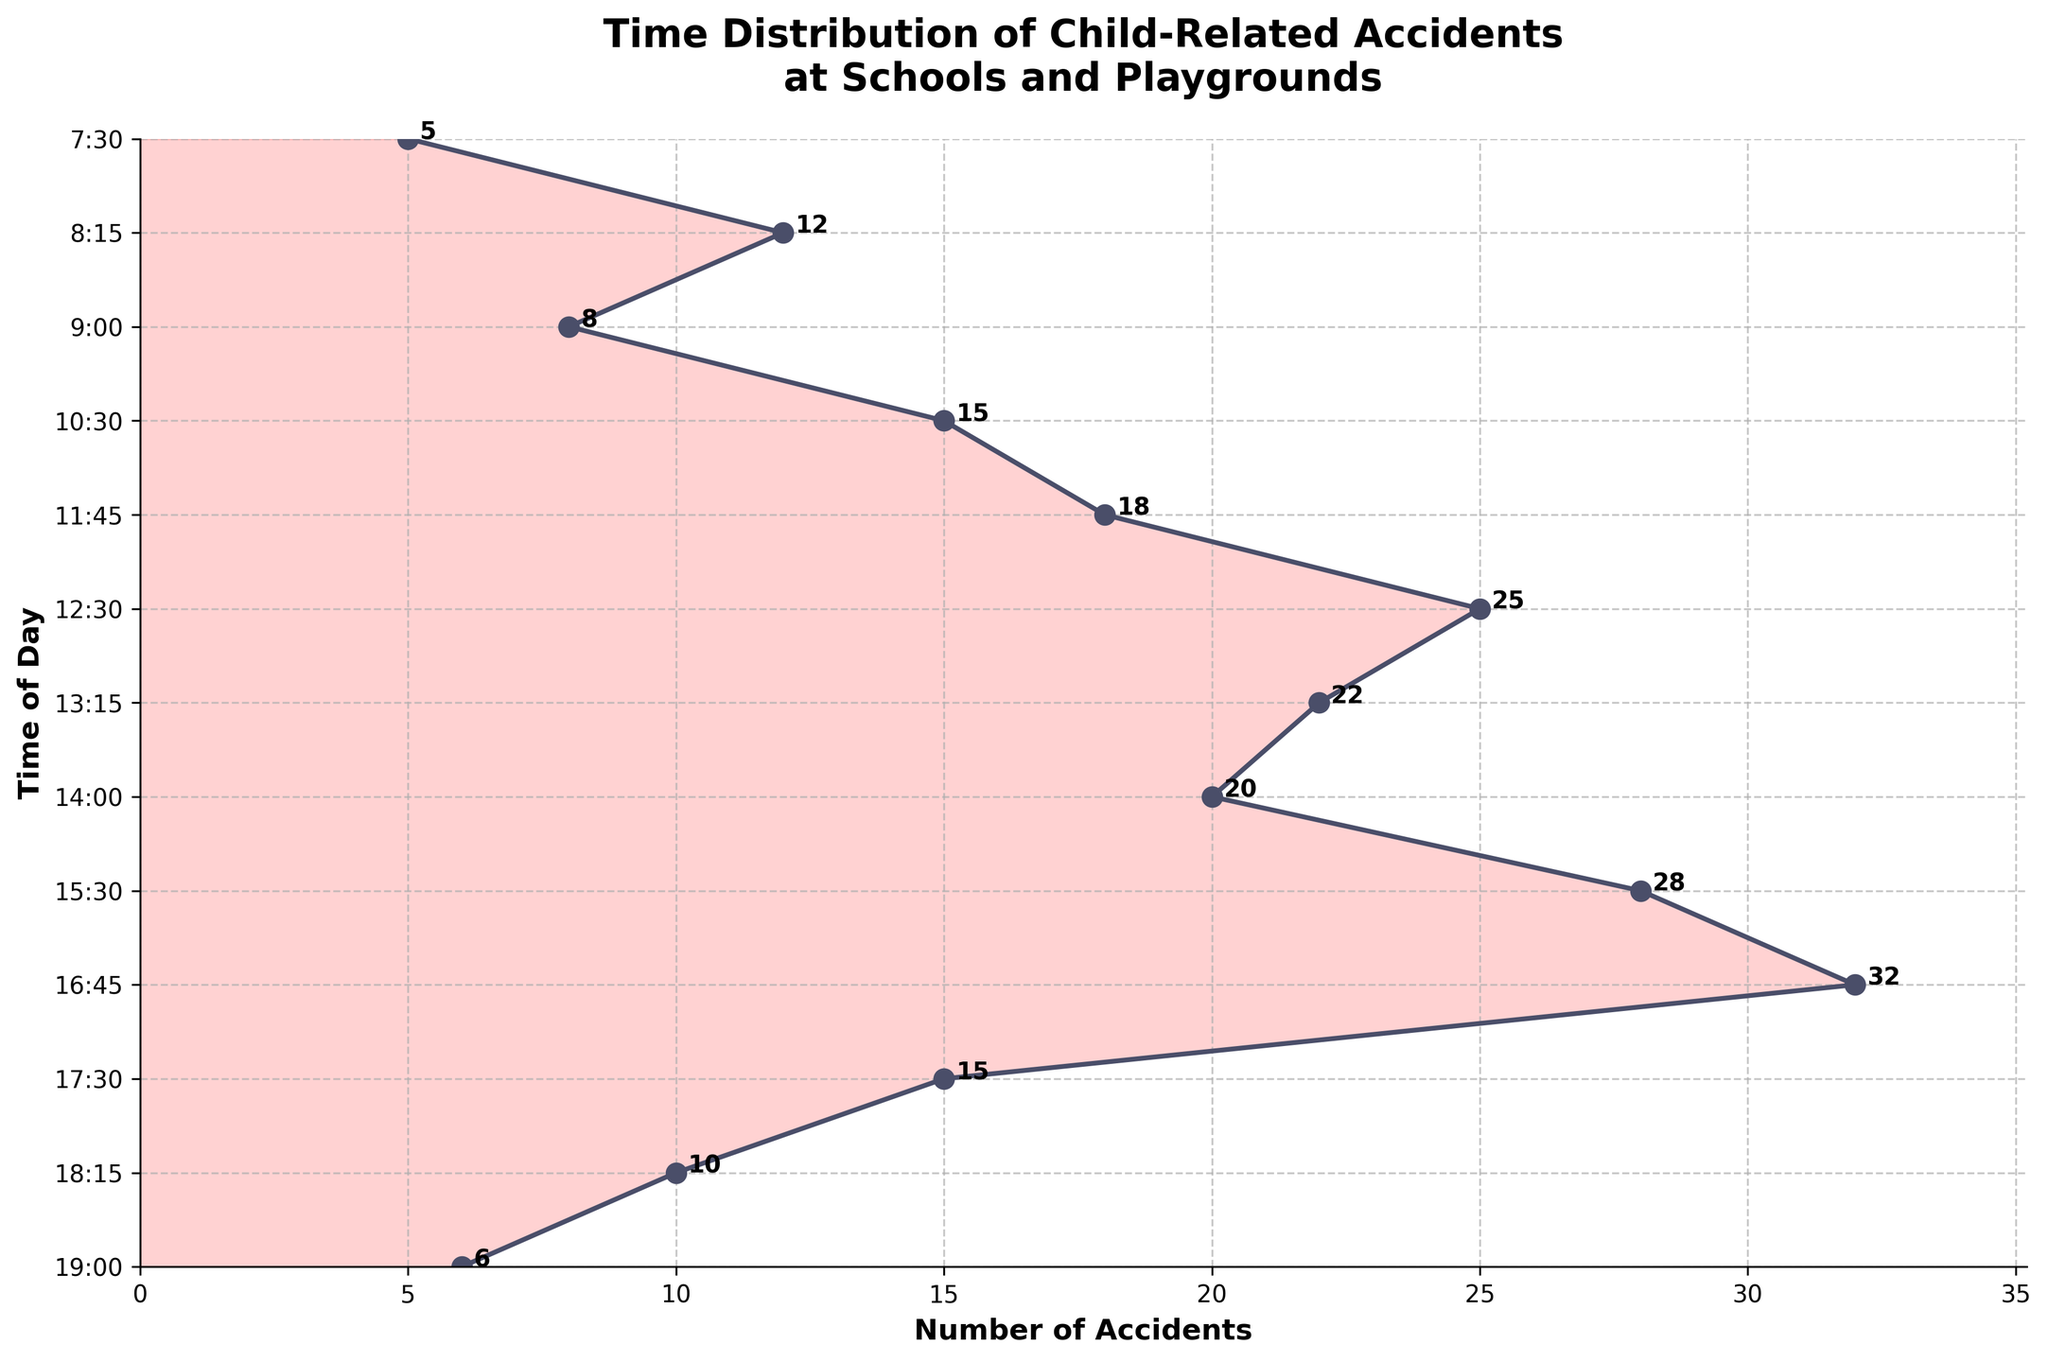When do accidents peak during the day based on the plot? The plot shows that the highest number of accidents occurs around 16:45, marked by the highest density peak.
Answer: 16:45 What is the total number of accidents recorded between 7:30 and 12:30? Adding the number of accidents from 7:30 (5), 8:15 (12), 9:00 (8), 10:30 (15), 11:45 (18), to 12:30 (25) results in 83 accidents.
Answer: 83 At what time does the number of accidents start decreasing in the evening? The plot shows a decrease in the number of accidents after 16:45.
Answer: After 16:45 What's the sum of accidents happening after 14:00? Adding the accidents occurring at 15:30 (28), 16:45 (32), 17:30 (15), 18:15 (10), and 19:00 (6) gives a total of 91 accidents.
Answer: 91 Which time period shows the second highest number of accidents? The plot indicates that the second highest number of accidents occurs at 15:30 with 28 accidents.
Answer: 15:30 By how much do the accidents at 12:30 exceed those at 10:30? The difference between the number of accidents at 12:30 (25) and 10:30 (15) is 10.
Answer: 10 How does the number of accidents at 8:15 compare to that at 10:30? The plot shows that 8:15 has 12 accidents and 10:30 has 15 accidents. Thus, 10:30 has 3 more accidents than 8:15.
Answer: 10:30 has 3 more During which timeframe do the most significant increasing trends in accidents occur? The plot shows a significant increase in accidents from 11:45 (18 accidents) to 12:30 (25 accidents) and then continuing to 15:30 (28 accidents) and 16:45 (32 accidents).
Answer: 11:45 to 16:45 